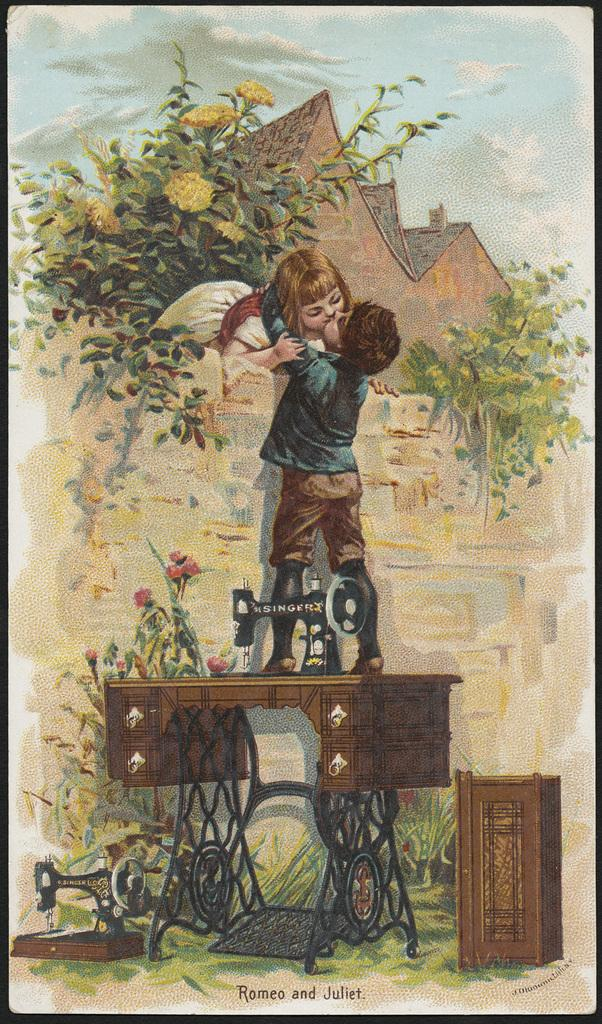What type of artwork is depicted in the image? The image is a painting. What are the two main subjects in the painting doing? A boy and girl are kissing in the painting. Can you describe the boy's position in the painting? The boy is standing on a sewing machine in the painting. What can be seen in the background of the painting? There is a building and plants in the background of the painting. What type of shop can be seen in the painting? There is: There is no shop present in the painting; it features a boy and girl kissing, a sewing machine, a building, and plants. 